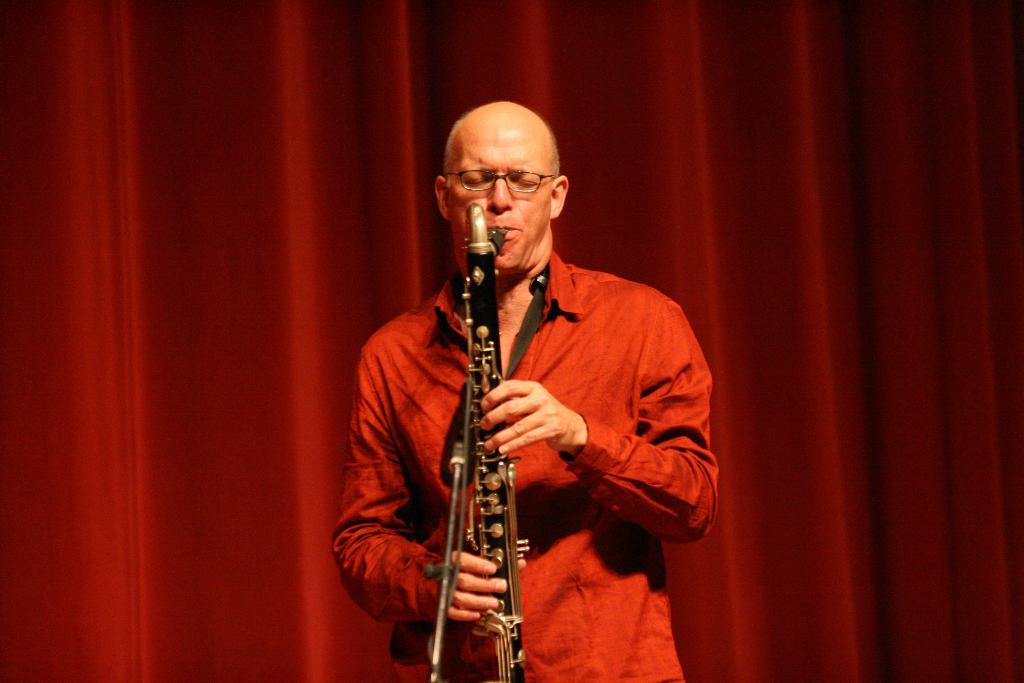What is the main subject in the foreground of the picture? There is a man in the foreground of the picture. What is the man wearing? The man is wearing a red shirt. What is the man doing in the picture? The man is playing a trumpet. What object is the man standing in front of? The man is in front of a microphone. What can be seen in the background of the picture? There is a red curtain in the background of the picture. What is the man's annual income based on the image? There is no information about the man's income in the image. Can you tell me how many pails are visible in the image? There are no pails present in the image. 